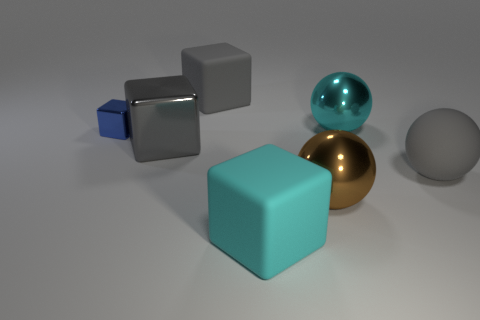Are there any big brown objects of the same shape as the tiny blue metal thing?
Offer a terse response. No. What number of large shiny balls are there?
Offer a very short reply. 2. Are the brown ball right of the cyan matte block and the tiny blue block made of the same material?
Ensure brevity in your answer.  Yes. Is there a cyan matte object of the same size as the gray matte ball?
Keep it short and to the point. Yes. There is a small blue object; does it have the same shape as the big matte thing that is in front of the big brown shiny thing?
Offer a very short reply. Yes. There is a brown metal object behind the cyan object that is in front of the blue cube; are there any cyan metal objects that are in front of it?
Ensure brevity in your answer.  No. The brown metal object is what size?
Keep it short and to the point. Large. How many other objects are there of the same color as the big rubber ball?
Your answer should be very brief. 2. There is a gray rubber thing that is left of the cyan cube; is it the same shape as the small blue thing?
Your response must be concise. Yes. What color is the big shiny object that is the same shape as the tiny blue object?
Offer a very short reply. Gray. 